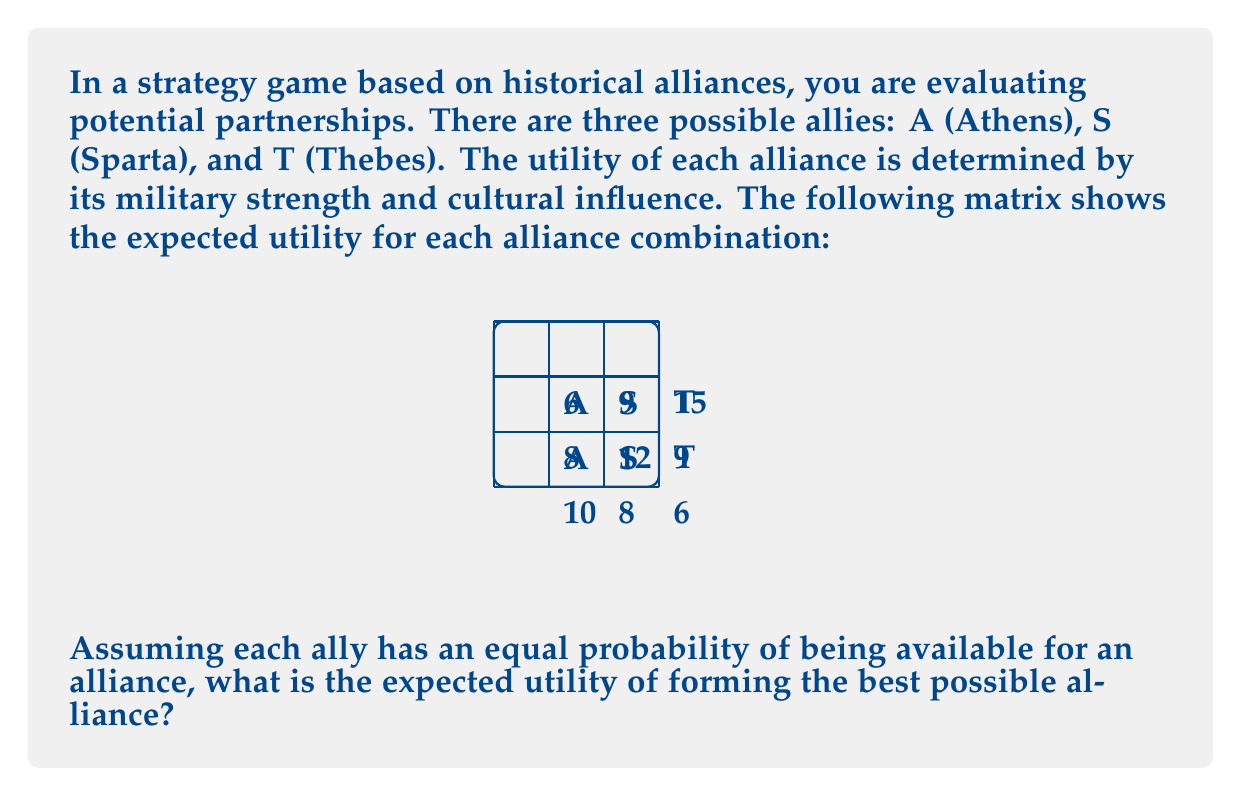What is the answer to this math problem? Let's approach this step-by-step:

1) First, we need to calculate the probability of each alliance formation. Since each ally has an equal probability of being available, we can use the following probabilities:

   $P(A) = P(S) = P(T) = \frac{1}{3}$
   $P(AS) = P(AT) = P(ST) = \frac{1}{3} \cdot \frac{1}{2} = \frac{1}{6}$
   $P(AST) = \frac{1}{3} \cdot \frac{1}{3} \cdot \frac{1}{3} = \frac{1}{27}$

2) Now, let's identify the best possible alliance for each scenario:

   Single ally: T (15)
   Two allies: ST (12)
   All three allies: AST (15)

3) We can now calculate the expected utility:

   $$E(U) = P(A) \cdot 10 + P(S) \cdot 12 + P(T) \cdot 15 + P(AS) \cdot 12 + P(AT) \cdot 9 + P(ST) \cdot 12 + P(AST) \cdot 15$$

4) Substituting the probabilities:

   $$E(U) = \frac{1}{3} \cdot 10 + \frac{1}{3} \cdot 12 + \frac{1}{3} \cdot 15 + \frac{1}{6} \cdot 12 + \frac{1}{6} \cdot 9 + \frac{1}{6} \cdot 12 + \frac{1}{27} \cdot 15$$

5) Simplifying:

   $$E(U) = \frac{10}{3} + 4 + 5 + 2 + \frac{3}{2} + 2 + \frac{5}{9} = \frac{37}{3} + \frac{35}{6} + \frac{5}{9} = \frac{74}{6} + \frac{35}{6} + \frac{5}{9} = \frac{109}{6} + \frac{5}{9}$$

6) Converting to a common denominator:

   $$E(U) = \frac{109}{6} + \frac{5}{9} = \frac{109 \cdot 3}{18} + \frac{5 \cdot 2}{18} = \frac{327}{18} + \frac{10}{18} = \frac{337}{18}$$

7) Calculating the final result:

   $$E(U) = \frac{337}{18} \approx 18.72$$
Answer: $\frac{337}{18}$ or approximately 18.72 